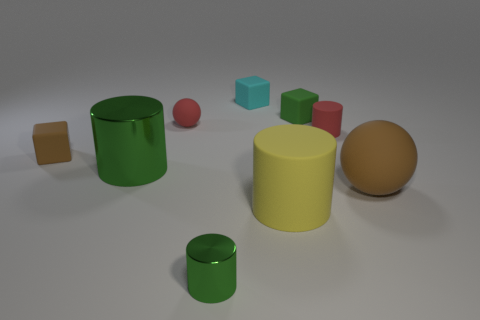Subtract 1 cylinders. How many cylinders are left? 3 Subtract all balls. How many objects are left? 7 Subtract all red rubber cylinders. Subtract all yellow matte objects. How many objects are left? 7 Add 7 tiny green shiny cylinders. How many tiny green shiny cylinders are left? 8 Add 3 large cyan metal balls. How many large cyan metal balls exist? 3 Subtract 0 purple blocks. How many objects are left? 9 